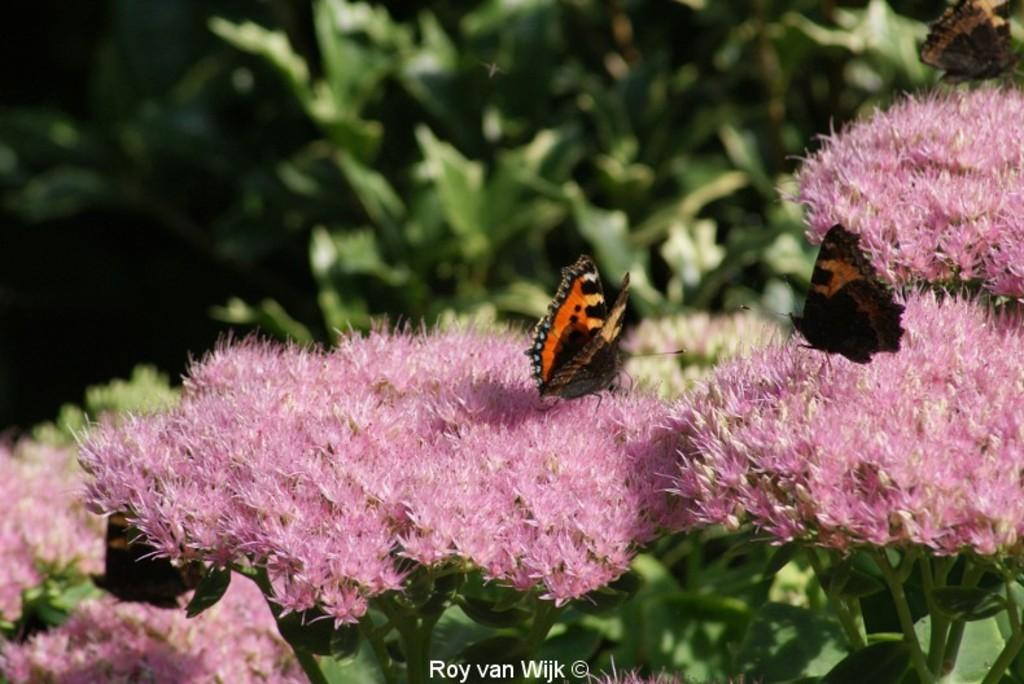What type of flowers can be seen in the image? There are pink color flowers in the image. Are there any animals or insects present in the image? Yes, there are butterflies sitting on the flowers. What is the color of the plants in the background of the image? The plants in the background of the image are green color. What type of stove is visible in the image? There is no stove present in the image; it features pink flowers and butterflies. Is the image taken during the winter season? The image does not provide any information about the season, but the presence of flowers suggests it is not winter. 